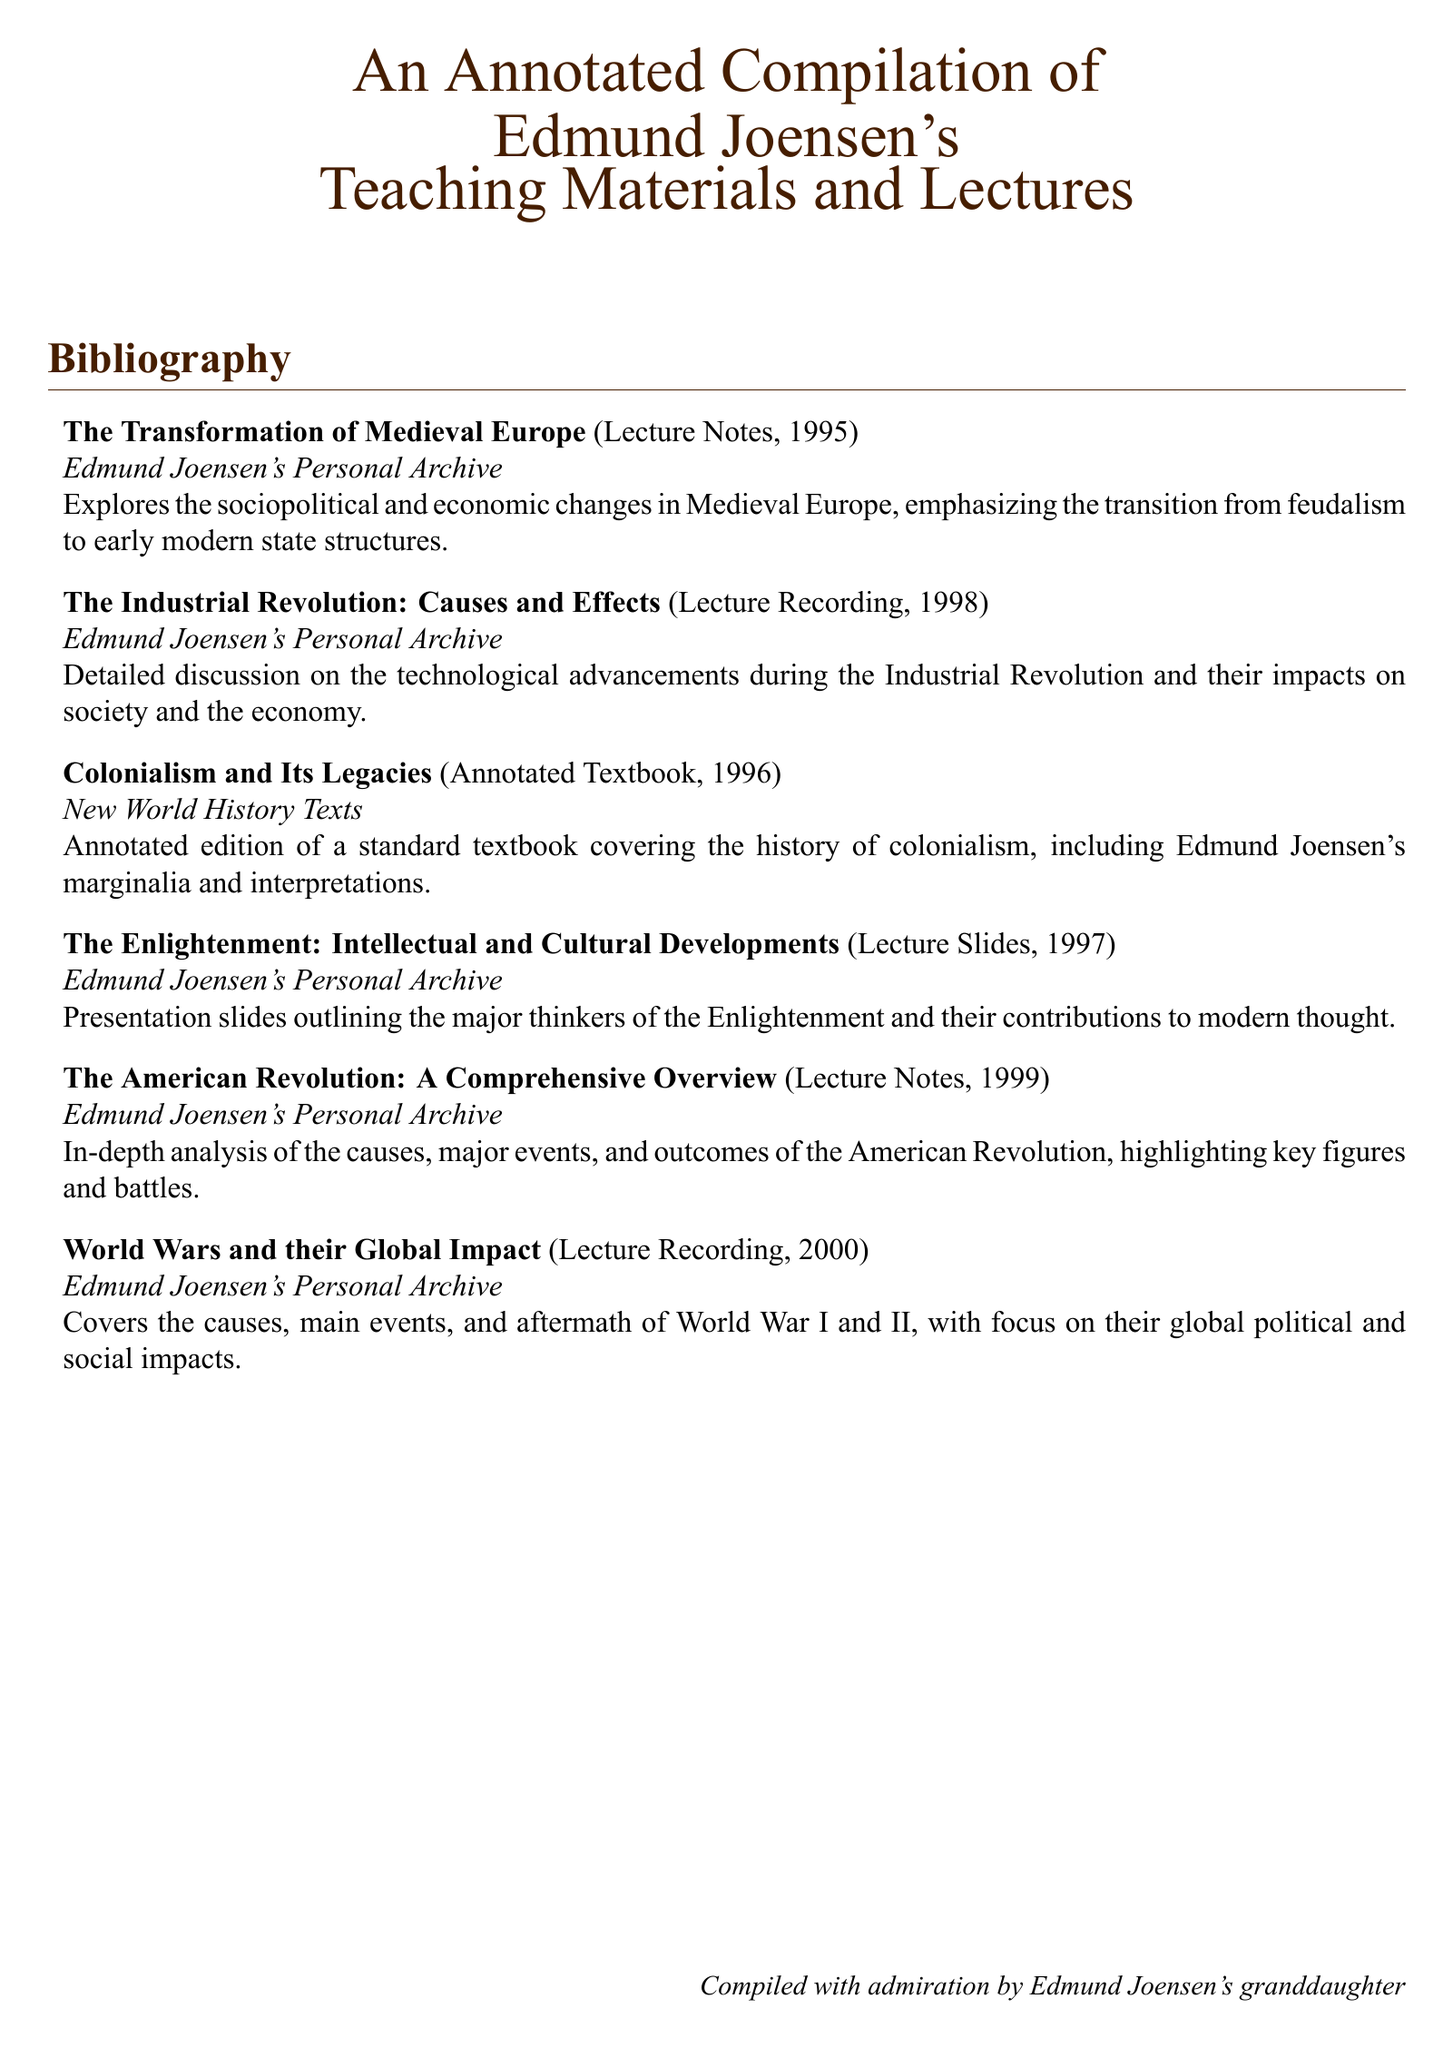What year was "The Industrial Revolution: Causes and Effects" recorded? The document specifies that the lecture recording was made in 1998.
Answer: 1998 What type of document is "Colonialism and Its Legacies"? This entry describes an annotated textbook as indicated in the document.
Answer: Annotated Textbook How many entries are listed in the bibliography? The document contains a total of six entries in the bibliography section.
Answer: 6 Which major historical period does "The Transformation of Medieval Europe" focus on? The title indicates a focus on Medieval Europe, specifically its sociopolitical and economic changes.
Answer: Medieval Europe What is the central topic of "World Wars and their Global Impact"? The entry describes a coverage of the causes, main events, and aftermath of the World Wars, emphasizing their global impact.
Answer: Global Impact In what year were the lecture notes for "The American Revolution: A Comprehensive Overview" created? The document states the notes were from 1999.
Answer: 1999 What is the primary focus of the presentation slides titled "The Enlightenment: Intellectual and Cultural Developments"? The entry mentions outlining major thinkers and their contributions to modern thought, indicating an emphasis on intellectual and cultural developments.
Answer: Major thinkers and contributions Who compiled this bibliography? The document concludes with a statement attributing the compilation to Edmund Joensen's granddaughter.
Answer: Granddaughter 